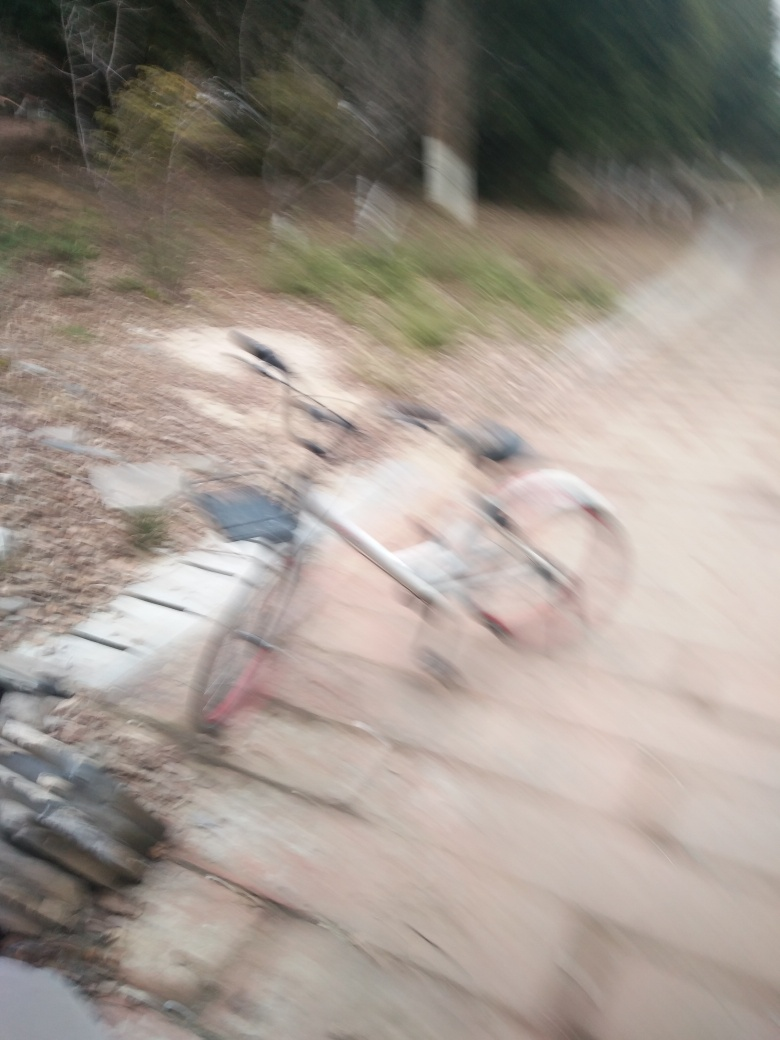What is the clarity of the photo?
A. Unclear
B. Very low
C. High
Answer with the option's letter from the given choices directly. The clarity of the photo can be categorized as 'Very low' (Option B), as the image appears significantly blurred, with no details in focus and an evident lack of sharpness. The motion blur suggests that the photo might have been taken while the camera or subject was moving, resulting in diminished clarity and a rough tactile feeling. 